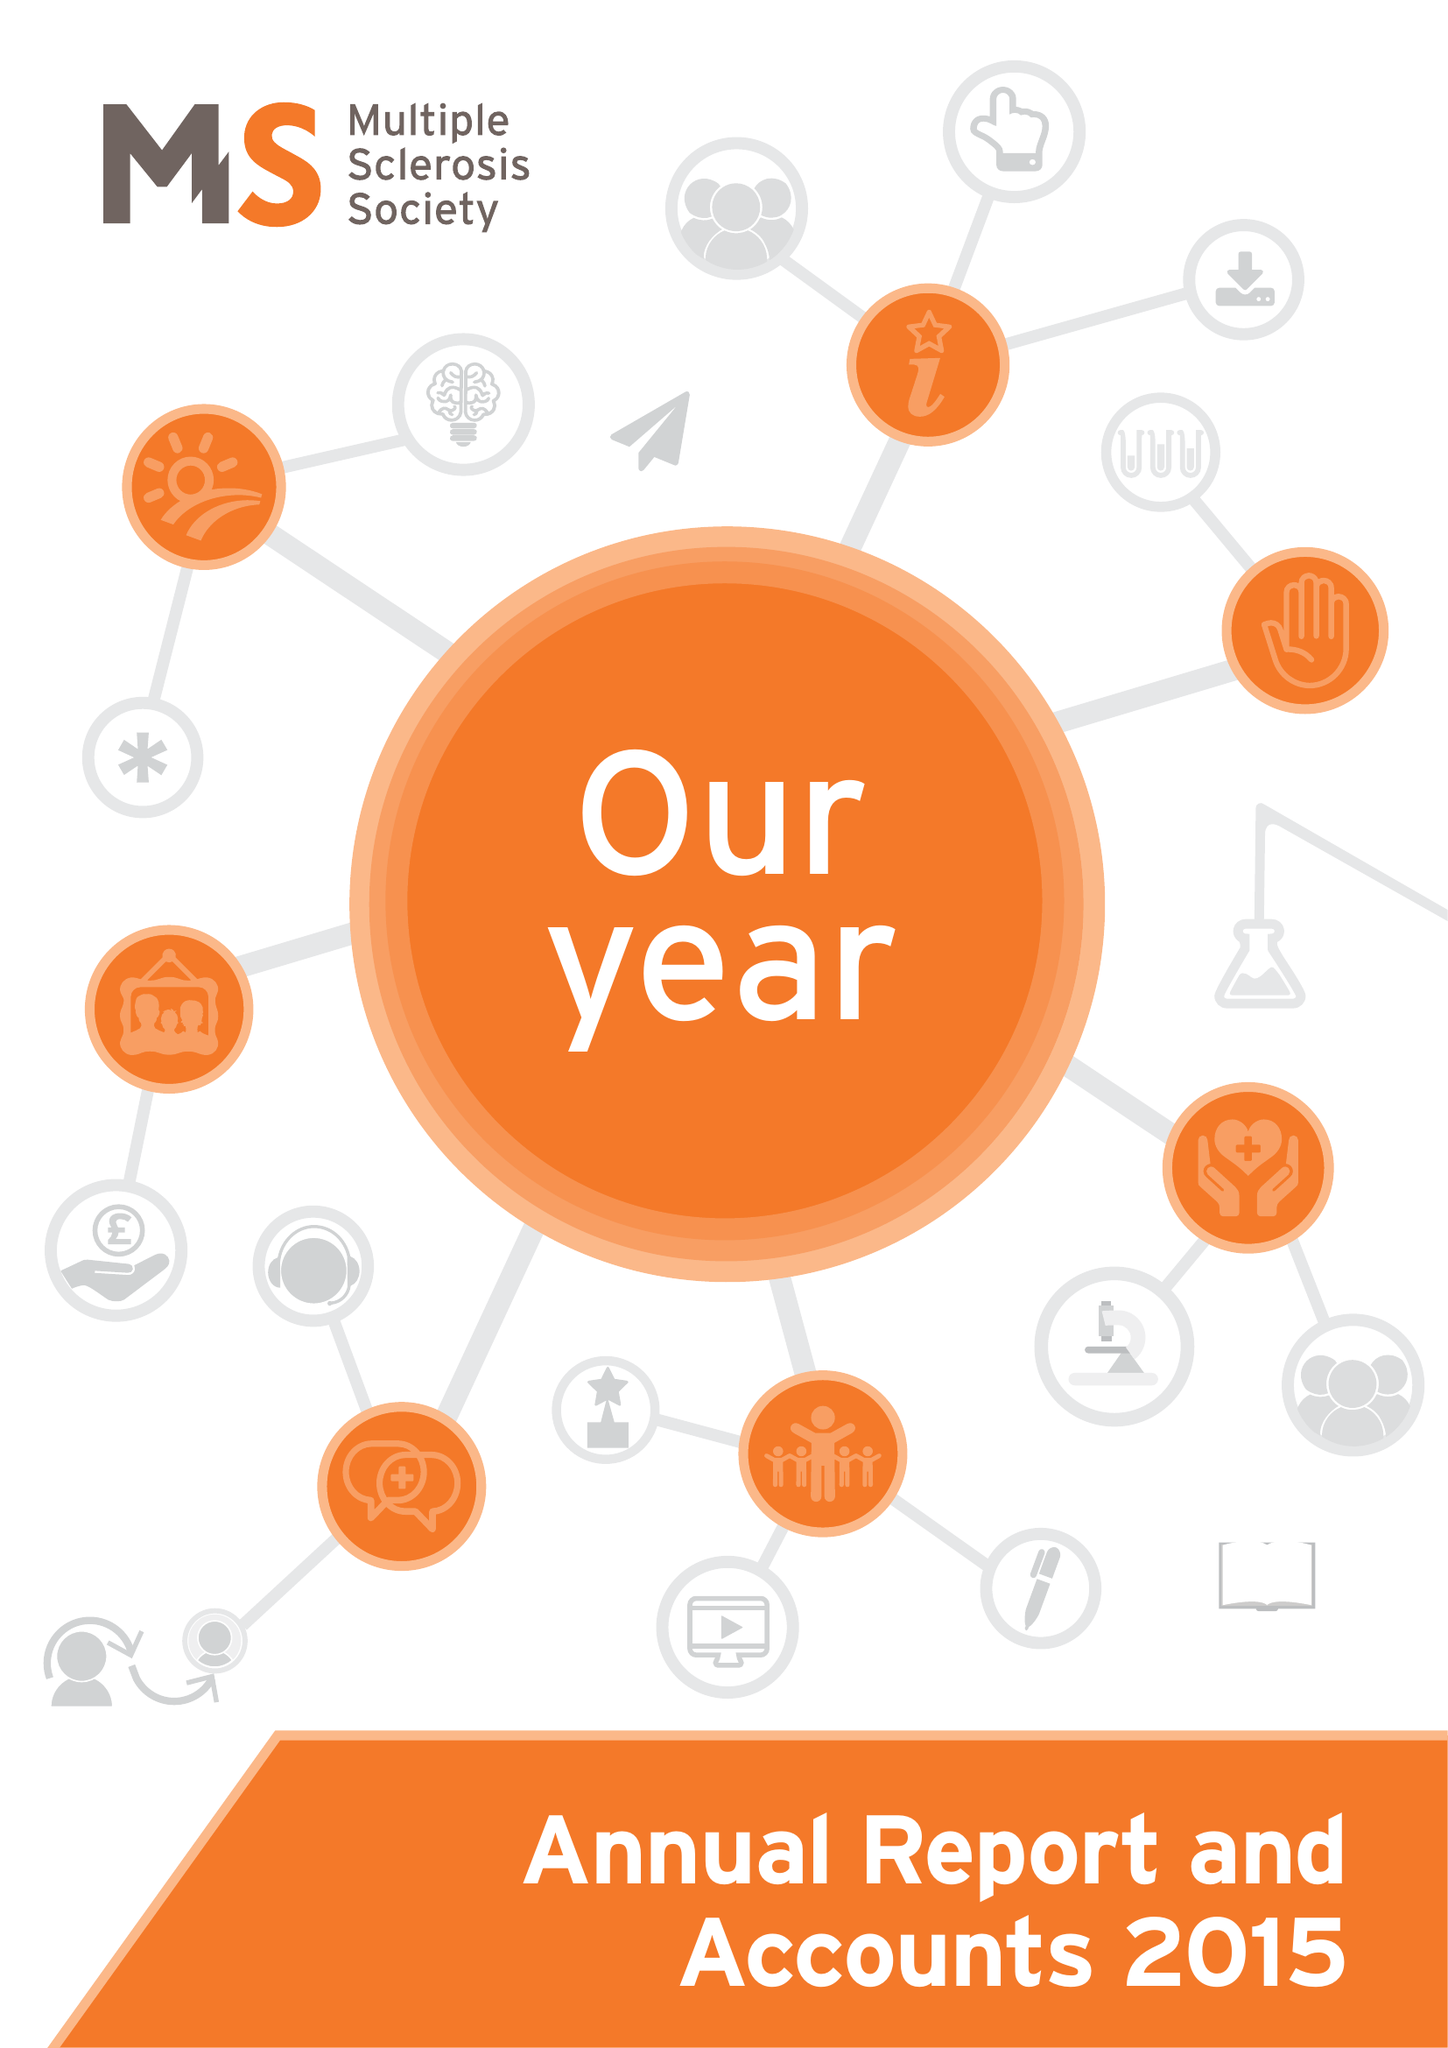What is the value for the income_annually_in_british_pounds?
Answer the question using a single word or phrase. 27743000.00 